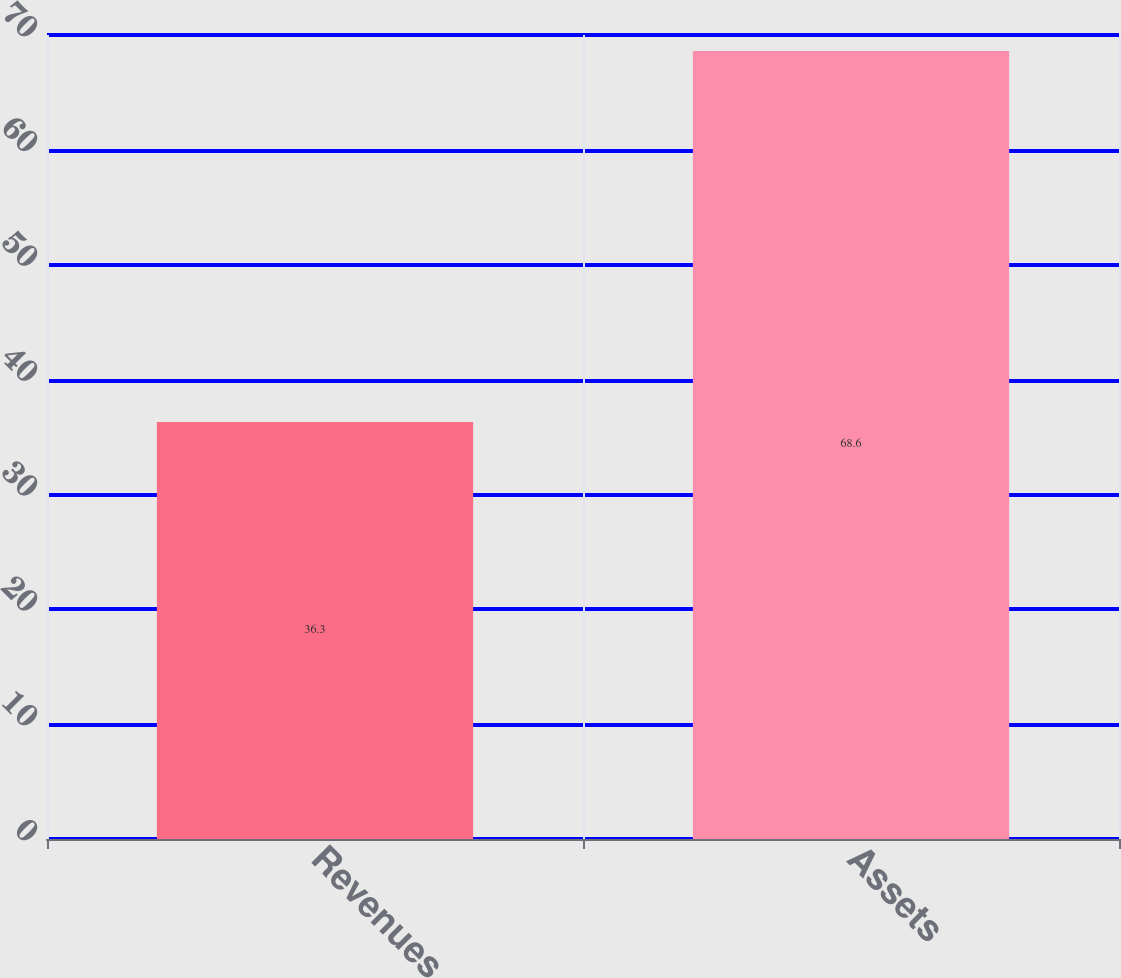Convert chart. <chart><loc_0><loc_0><loc_500><loc_500><bar_chart><fcel>Revenues<fcel>Assets<nl><fcel>36.3<fcel>68.6<nl></chart> 